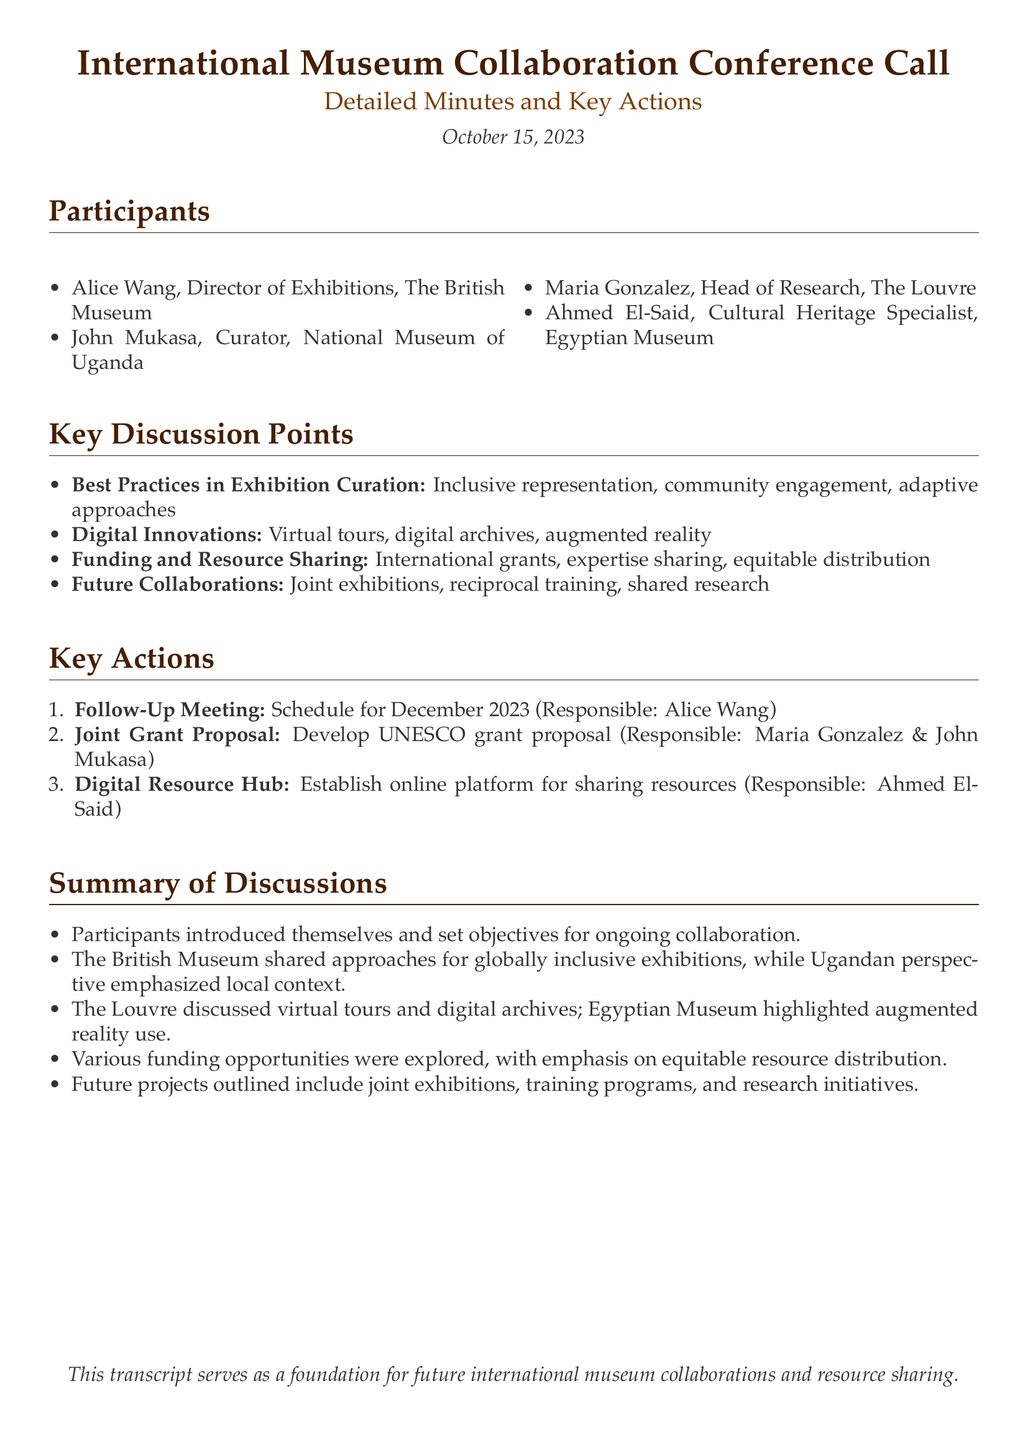What is the date of the conference call? The date is explicitly mentioned in the document as October 15, 2023.
Answer: October 15, 2023 Who is responsible for the follow-up meeting? The document states that Alice Wang is assigned to schedule the follow-up meeting.
Answer: Alice Wang What key topic involves technology in exhibitions? The document mentions "Digital Innovations" as a key discussion point concerning technology in exhibitions.
Answer: Digital Innovations How many participants were identified in the meeting? The document lists five participants who were part of the conference call.
Answer: Four Which museum is John Mukasa associated with? The document clearly states that John Mukasa is a curator at the National Museum of Uganda.
Answer: National Museum of Uganda What type of joint effort is suggested by the participants for future work? The document highlights "Joint exhibitions" as one of the areas for future collaboration mentioned by the participants.
Answer: Joint exhibitions What proposal are Maria Gonzalez and John Mukasa developing? The document indicates that they are responsible for developing a UNESCO grant proposal.
Answer: UNESCO grant proposal What is the main goal of the discussed future projects? The document explains that the future projects focus on collaborative efforts such as exhibitions and training.
Answer: Collaborative efforts 